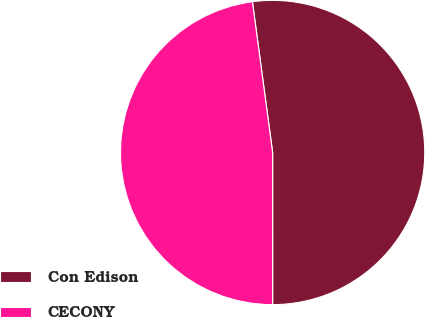Convert chart to OTSL. <chart><loc_0><loc_0><loc_500><loc_500><pie_chart><fcel>Con Edison<fcel>CECONY<nl><fcel>52.12%<fcel>47.88%<nl></chart> 